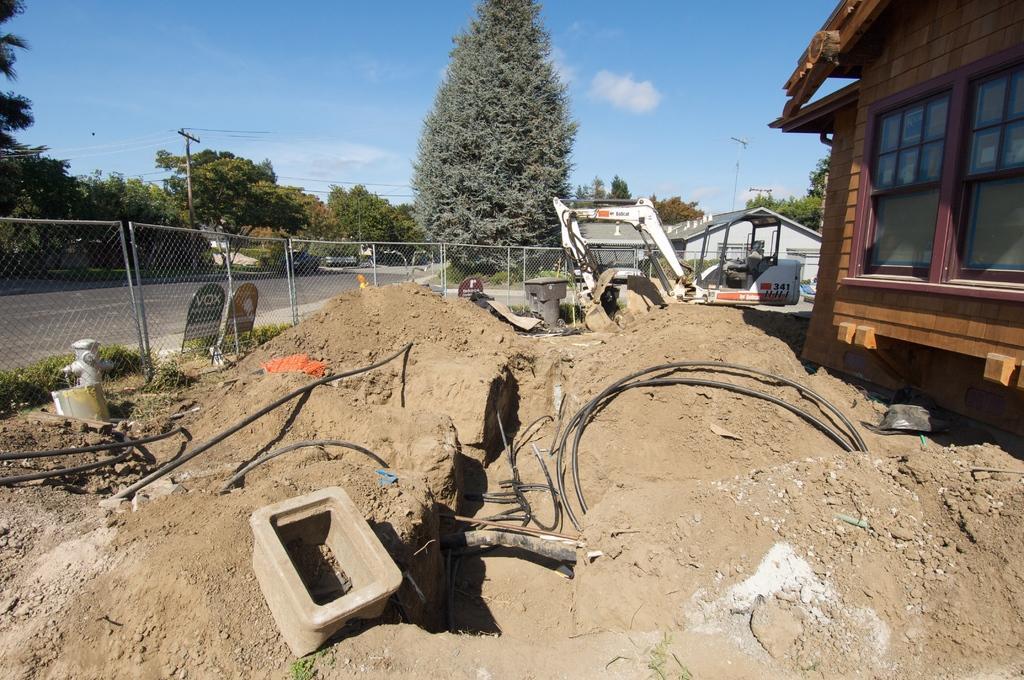Please provide a concise description of this image. In this image we can see sand and few objects on the sand, there is a fence, boards near the fence, a fire hydrant, grass, few trees, current pole with wires, buildings on the right side and sky in the background. 